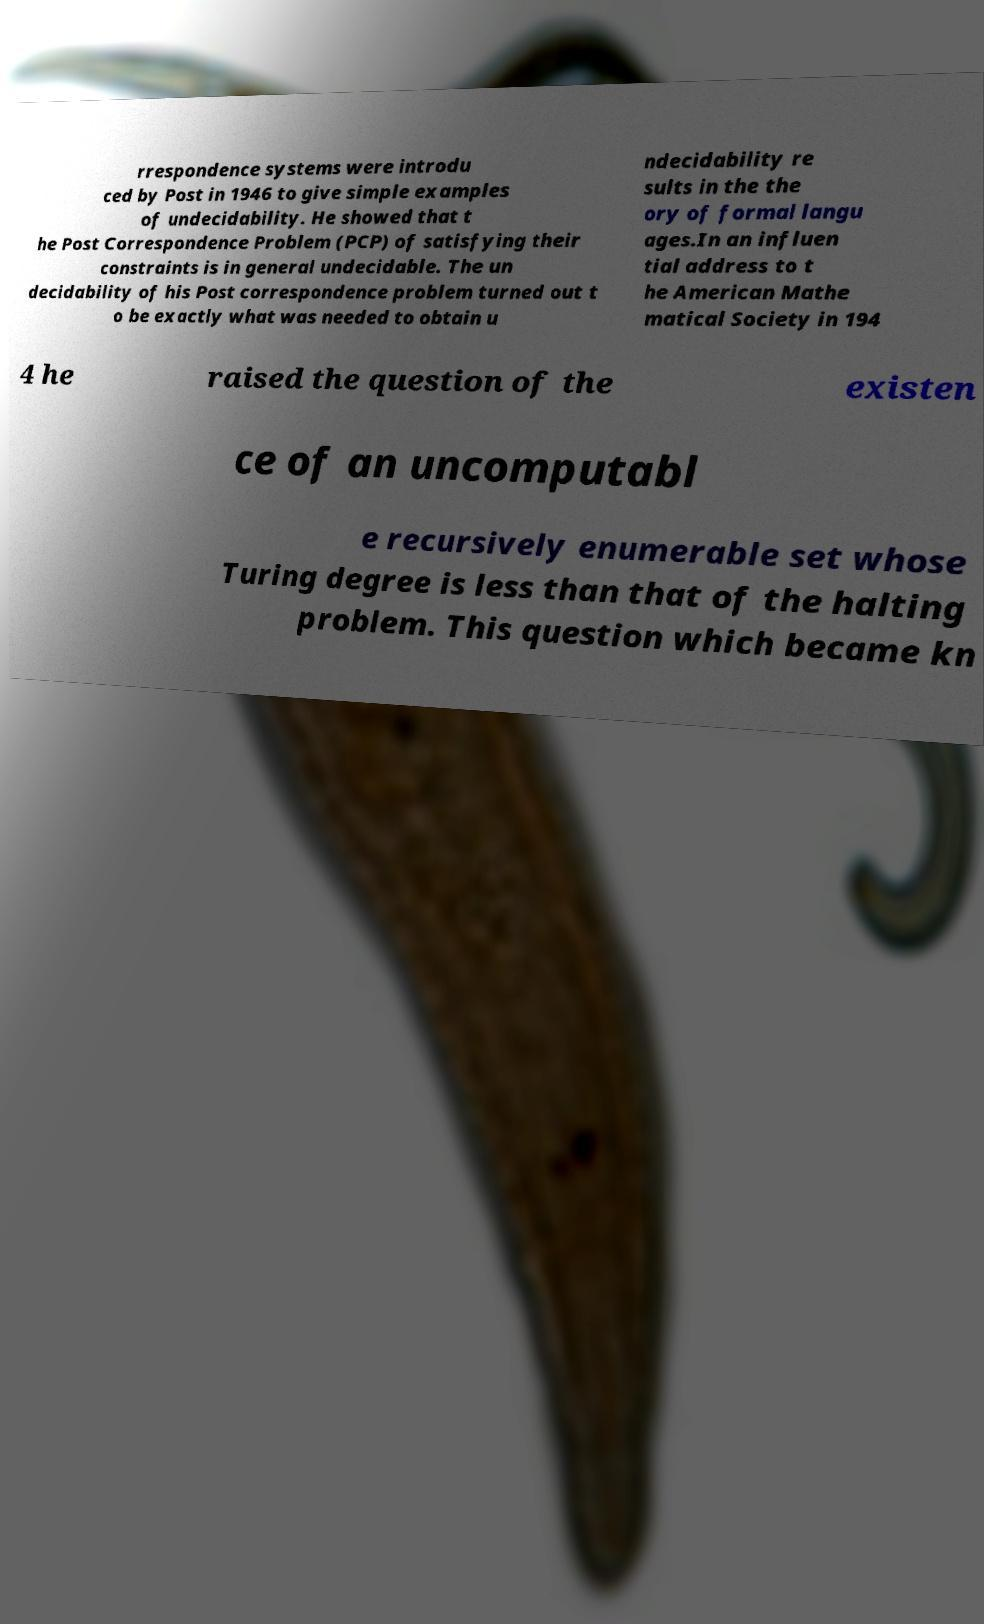I need the written content from this picture converted into text. Can you do that? rrespondence systems were introdu ced by Post in 1946 to give simple examples of undecidability. He showed that t he Post Correspondence Problem (PCP) of satisfying their constraints is in general undecidable. The un decidability of his Post correspondence problem turned out t o be exactly what was needed to obtain u ndecidability re sults in the the ory of formal langu ages.In an influen tial address to t he American Mathe matical Society in 194 4 he raised the question of the existen ce of an uncomputabl e recursively enumerable set whose Turing degree is less than that of the halting problem. This question which became kn 